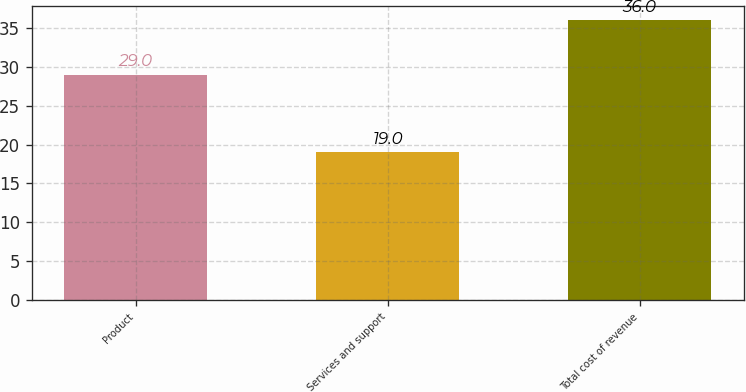Convert chart to OTSL. <chart><loc_0><loc_0><loc_500><loc_500><bar_chart><fcel>Product<fcel>Services and support<fcel>Total cost of revenue<nl><fcel>29<fcel>19<fcel>36<nl></chart> 